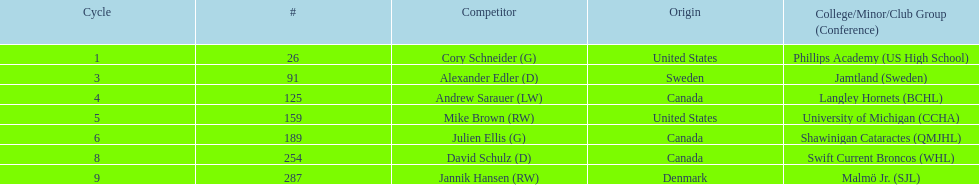List only the american players. Cory Schneider (G), Mike Brown (RW). 